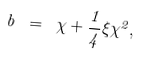Convert formula to latex. <formula><loc_0><loc_0><loc_500><loc_500>b \ = \ \chi + { \frac { 1 } { 4 } } \xi \chi ^ { 2 } ,</formula> 